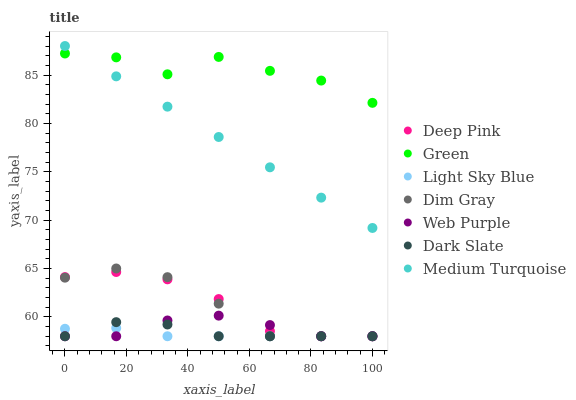Does Light Sky Blue have the minimum area under the curve?
Answer yes or no. Yes. Does Green have the maximum area under the curve?
Answer yes or no. Yes. Does Medium Turquoise have the minimum area under the curve?
Answer yes or no. No. Does Medium Turquoise have the maximum area under the curve?
Answer yes or no. No. Is Medium Turquoise the smoothest?
Answer yes or no. Yes. Is Green the roughest?
Answer yes or no. Yes. Is Dark Slate the smoothest?
Answer yes or no. No. Is Dark Slate the roughest?
Answer yes or no. No. Does Dim Gray have the lowest value?
Answer yes or no. Yes. Does Medium Turquoise have the lowest value?
Answer yes or no. No. Does Medium Turquoise have the highest value?
Answer yes or no. Yes. Does Dark Slate have the highest value?
Answer yes or no. No. Is Dim Gray less than Medium Turquoise?
Answer yes or no. Yes. Is Green greater than Dark Slate?
Answer yes or no. Yes. Does Light Sky Blue intersect Deep Pink?
Answer yes or no. Yes. Is Light Sky Blue less than Deep Pink?
Answer yes or no. No. Is Light Sky Blue greater than Deep Pink?
Answer yes or no. No. Does Dim Gray intersect Medium Turquoise?
Answer yes or no. No. 